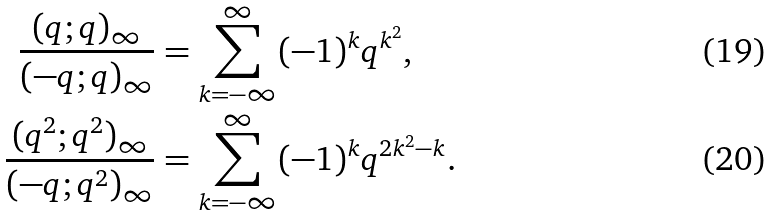<formula> <loc_0><loc_0><loc_500><loc_500>\frac { ( q ; q ) _ { \infty } } { ( - q ; q ) _ { \infty } } & = \sum _ { k = - \infty } ^ { \infty } ( - 1 ) ^ { k } q ^ { k ^ { 2 } } , \\ \frac { ( q ^ { 2 } ; q ^ { 2 } ) _ { \infty } } { ( - q ; q ^ { 2 } ) _ { \infty } } & = \sum _ { k = - \infty } ^ { \infty } ( - 1 ) ^ { k } q ^ { 2 k ^ { 2 } - k } .</formula> 